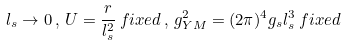<formula> <loc_0><loc_0><loc_500><loc_500>l _ { s } \rightarrow 0 \, , \, U = \frac { r } { l _ { s } ^ { 2 } } \, f i x e d \, , \, g _ { Y M } ^ { 2 } = ( 2 \pi ) ^ { 4 } g _ { s } l _ { s } ^ { 3 } \, f i x e d</formula> 